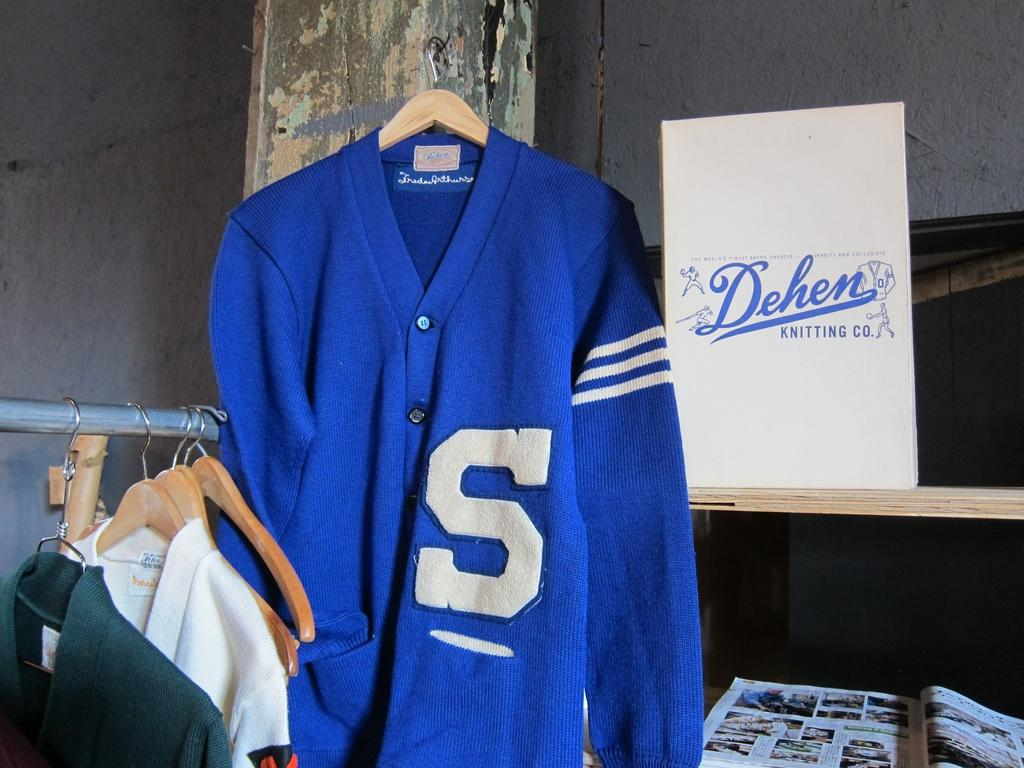<image>
Summarize the visual content of the image. A blue cardigan with S on the front hangs beside a sign for the Dehen knitting company. 